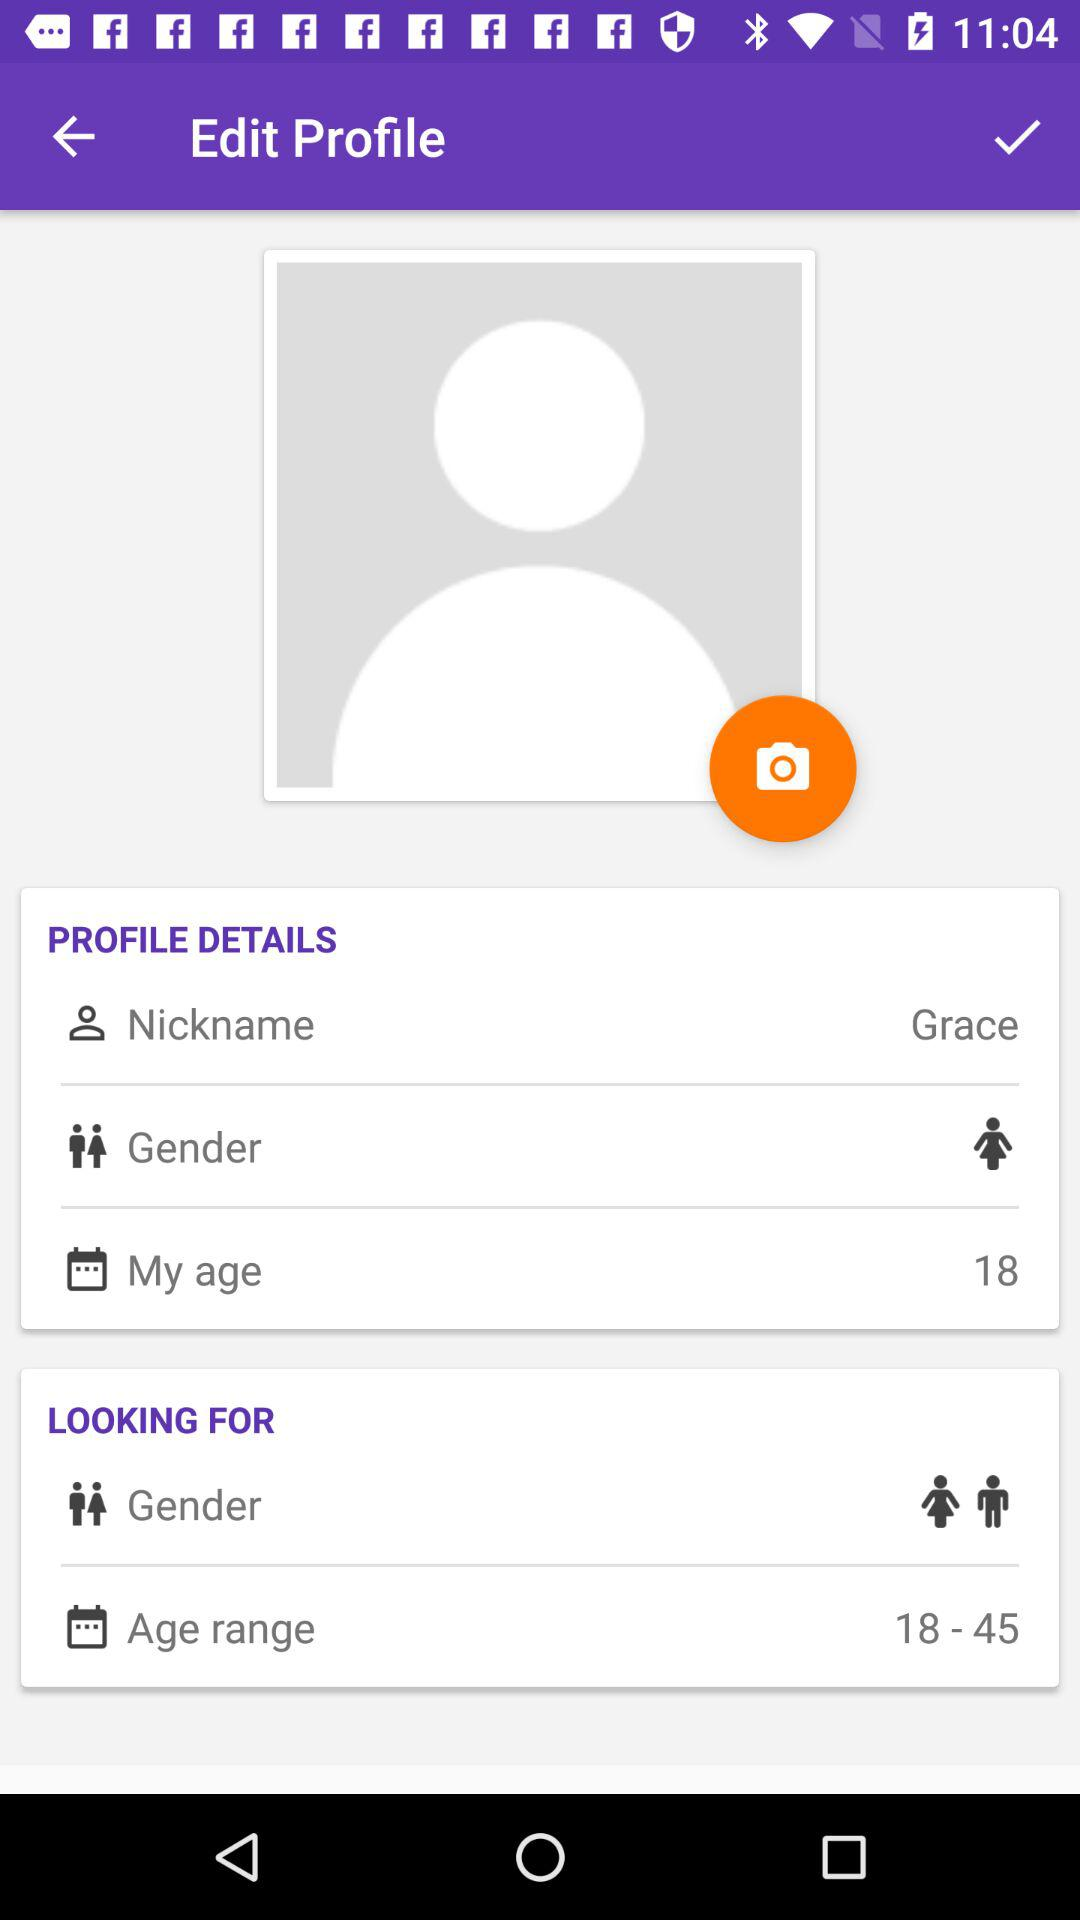What is the nickname? The nickname is Grace. 